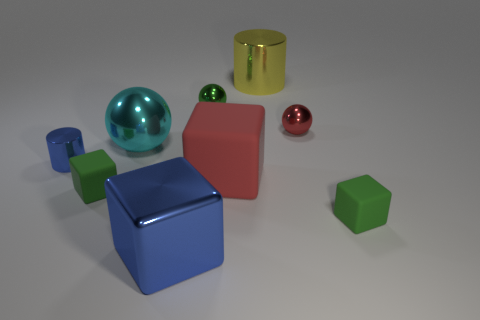What is the relative positioning of the green cube in relation to the other objects? The smaller green cube is positioned to the left and front of the big blue block, and there is also a green cube to the right of the blue block, partially hidden from view. 